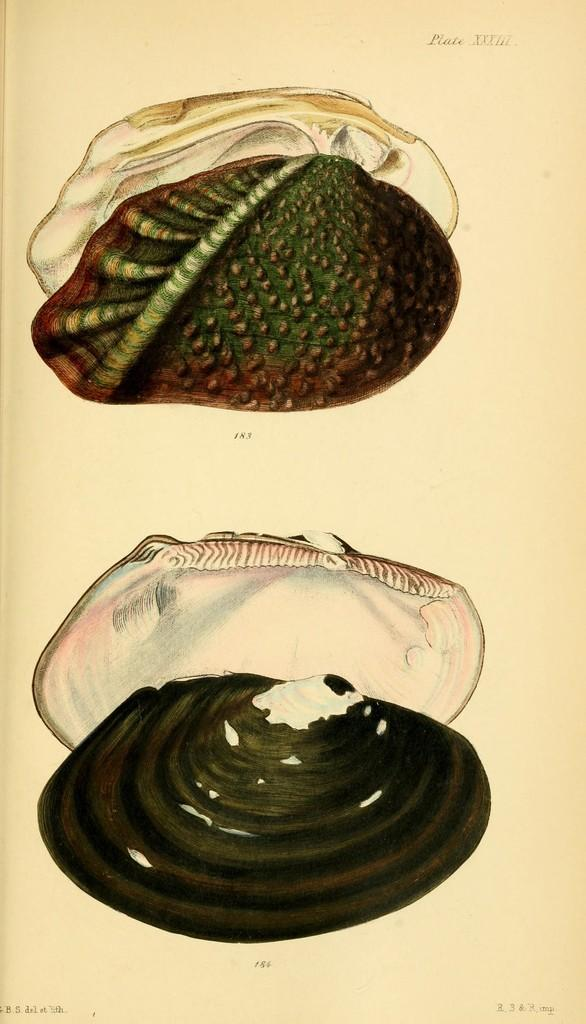What objects are present in the image? There are two seashells in the image. What is written below the seashells? There is text written below the seashells. What type of horn can be seen in the image? There is no horn present in the image; it features two seashells and text. 